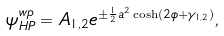Convert formula to latex. <formula><loc_0><loc_0><loc_500><loc_500>\psi _ { H P } ^ { w p } = A _ { 1 , 2 } e ^ { \pm \frac { 1 } { 2 } a ^ { 2 } \cosh ( 2 \phi + \gamma _ { 1 , 2 } ) } , \\</formula> 